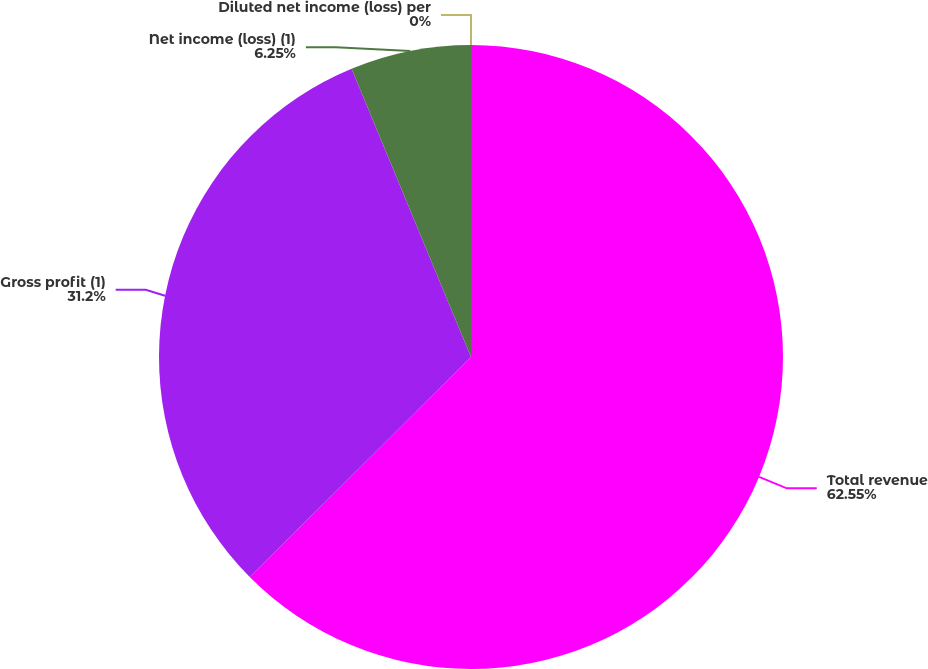Convert chart to OTSL. <chart><loc_0><loc_0><loc_500><loc_500><pie_chart><fcel>Total revenue<fcel>Gross profit (1)<fcel>Net income (loss) (1)<fcel>Diluted net income (loss) per<nl><fcel>62.54%<fcel>31.2%<fcel>6.25%<fcel>0.0%<nl></chart> 